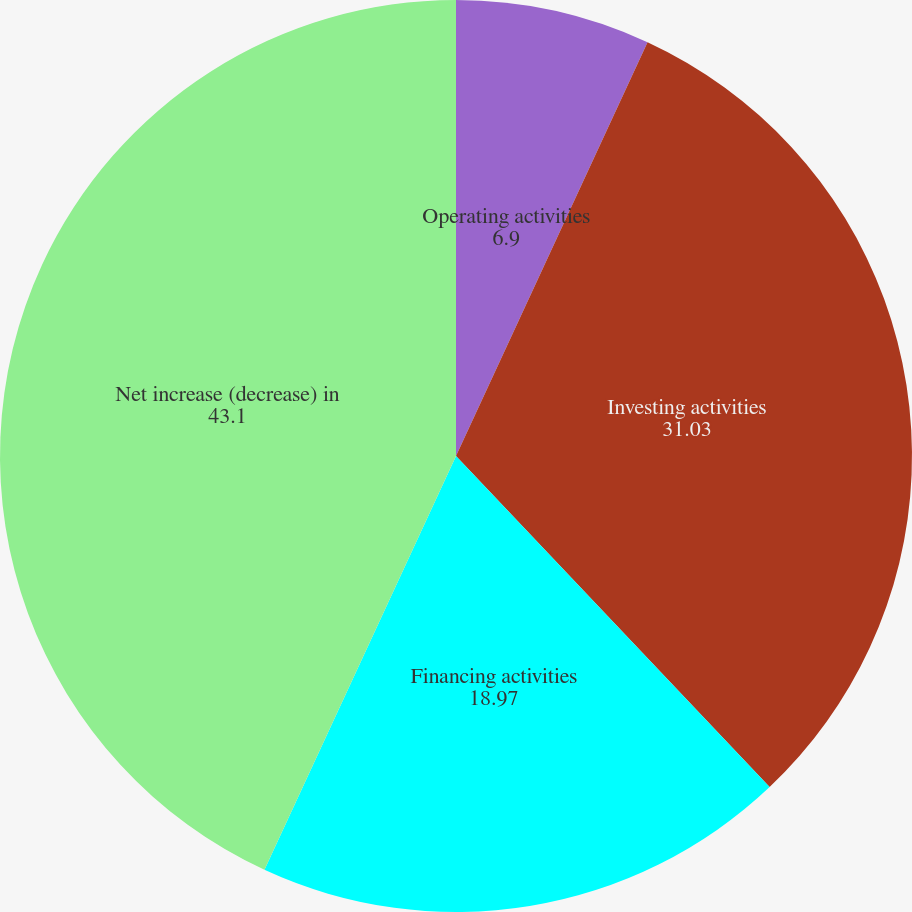Convert chart to OTSL. <chart><loc_0><loc_0><loc_500><loc_500><pie_chart><fcel>Operating activities<fcel>Investing activities<fcel>Financing activities<fcel>Net increase (decrease) in<nl><fcel>6.9%<fcel>31.03%<fcel>18.97%<fcel>43.1%<nl></chart> 